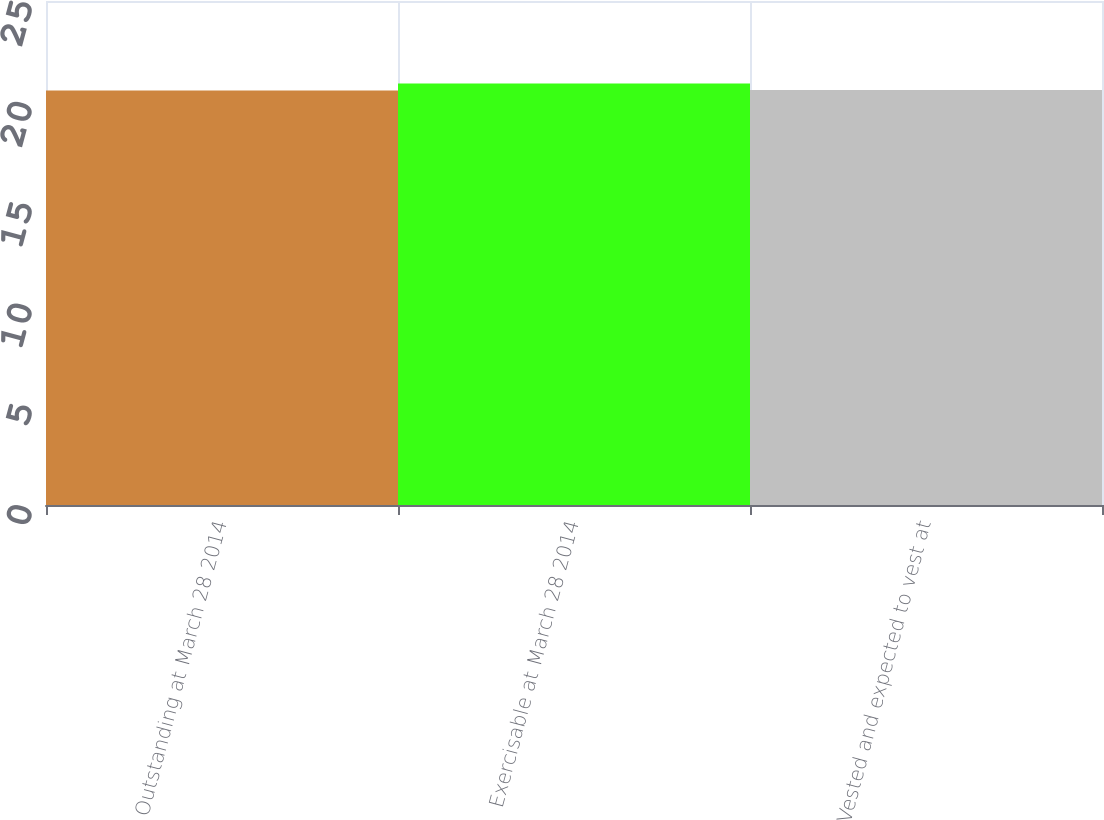Convert chart. <chart><loc_0><loc_0><loc_500><loc_500><bar_chart><fcel>Outstanding at March 28 2014<fcel>Exercisable at March 28 2014<fcel>Vested and expected to vest at<nl><fcel>20.56<fcel>20.91<fcel>20.59<nl></chart> 